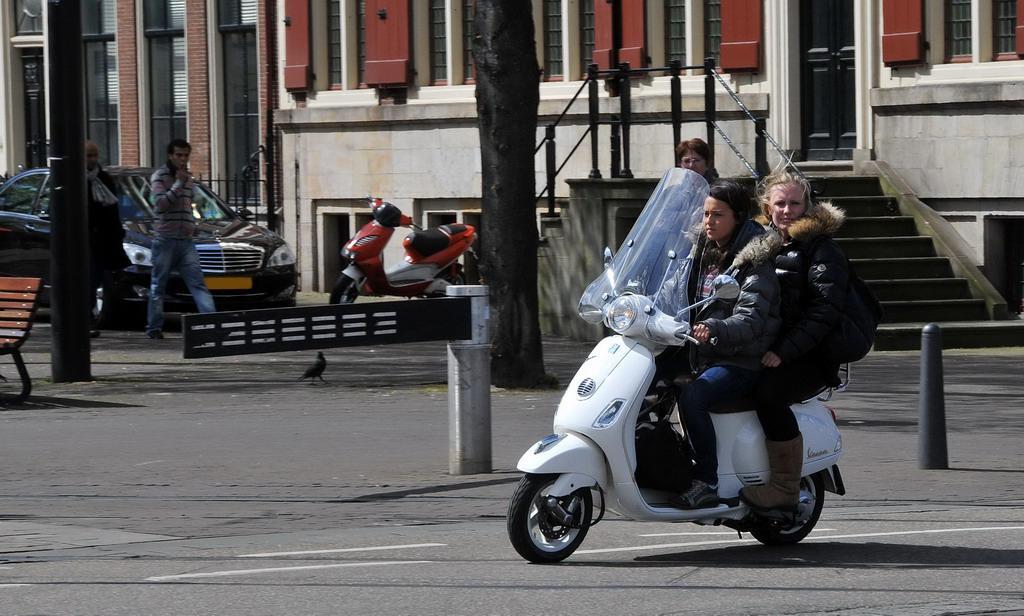How would you summarize this image in a sentence or two? In this image, There is an outside view. There are two persons sitting on bike and wearing clothes. There are two persons on the left of the image walking on the road. There is a car behind these two persons. There is a bike in the center of the image. There is a building at the top of the image. There is a pole and bench in the top left of the image. 